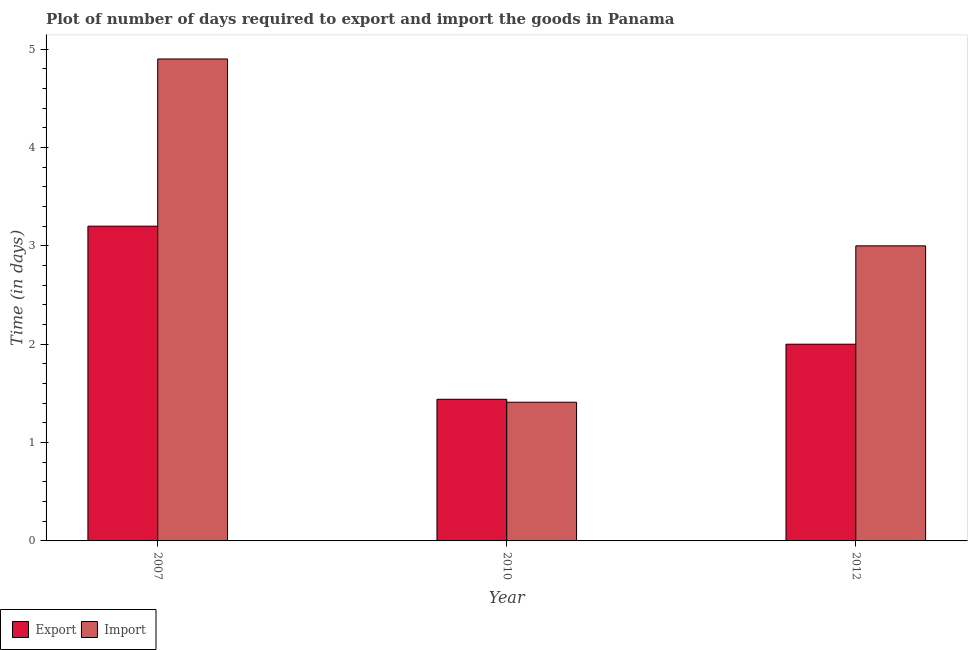How many different coloured bars are there?
Offer a very short reply. 2. What is the label of the 3rd group of bars from the left?
Your answer should be compact. 2012. In how many cases, is the number of bars for a given year not equal to the number of legend labels?
Make the answer very short. 0. Across all years, what is the minimum time required to export?
Make the answer very short. 1.44. In which year was the time required to export minimum?
Keep it short and to the point. 2010. What is the total time required to import in the graph?
Your answer should be very brief. 9.31. What is the difference between the time required to export in 2007 and that in 2012?
Your answer should be very brief. 1.2. What is the difference between the time required to import in 2012 and the time required to export in 2007?
Offer a terse response. -1.9. What is the average time required to export per year?
Offer a very short reply. 2.21. In how many years, is the time required to import greater than 1.2 days?
Offer a very short reply. 3. What is the ratio of the time required to export in 2010 to that in 2012?
Offer a very short reply. 0.72. Is the difference between the time required to import in 2010 and 2012 greater than the difference between the time required to export in 2010 and 2012?
Ensure brevity in your answer.  No. What is the difference between the highest and the second highest time required to export?
Keep it short and to the point. 1.2. What is the difference between the highest and the lowest time required to import?
Provide a short and direct response. 3.49. In how many years, is the time required to import greater than the average time required to import taken over all years?
Ensure brevity in your answer.  1. What does the 2nd bar from the left in 2010 represents?
Make the answer very short. Import. What does the 1st bar from the right in 2012 represents?
Provide a short and direct response. Import. How many bars are there?
Keep it short and to the point. 6. What is the difference between two consecutive major ticks on the Y-axis?
Make the answer very short. 1. Are the values on the major ticks of Y-axis written in scientific E-notation?
Your answer should be compact. No. Does the graph contain any zero values?
Offer a terse response. No. Where does the legend appear in the graph?
Your answer should be compact. Bottom left. What is the title of the graph?
Your response must be concise. Plot of number of days required to export and import the goods in Panama. Does "Taxes on profits and capital gains" appear as one of the legend labels in the graph?
Your answer should be compact. No. What is the label or title of the Y-axis?
Provide a succinct answer. Time (in days). What is the Time (in days) of Import in 2007?
Offer a very short reply. 4.9. What is the Time (in days) in Export in 2010?
Your response must be concise. 1.44. What is the Time (in days) of Import in 2010?
Make the answer very short. 1.41. What is the Time (in days) in Export in 2012?
Keep it short and to the point. 2. Across all years, what is the maximum Time (in days) in Export?
Your answer should be compact. 3.2. Across all years, what is the maximum Time (in days) in Import?
Keep it short and to the point. 4.9. Across all years, what is the minimum Time (in days) in Export?
Keep it short and to the point. 1.44. Across all years, what is the minimum Time (in days) of Import?
Offer a terse response. 1.41. What is the total Time (in days) in Export in the graph?
Make the answer very short. 6.64. What is the total Time (in days) in Import in the graph?
Your response must be concise. 9.31. What is the difference between the Time (in days) of Export in 2007 and that in 2010?
Make the answer very short. 1.76. What is the difference between the Time (in days) in Import in 2007 and that in 2010?
Give a very brief answer. 3.49. What is the difference between the Time (in days) in Export in 2007 and that in 2012?
Provide a succinct answer. 1.2. What is the difference between the Time (in days) of Import in 2007 and that in 2012?
Your answer should be compact. 1.9. What is the difference between the Time (in days) of Export in 2010 and that in 2012?
Your response must be concise. -0.56. What is the difference between the Time (in days) in Import in 2010 and that in 2012?
Keep it short and to the point. -1.59. What is the difference between the Time (in days) in Export in 2007 and the Time (in days) in Import in 2010?
Offer a very short reply. 1.79. What is the difference between the Time (in days) of Export in 2010 and the Time (in days) of Import in 2012?
Your response must be concise. -1.56. What is the average Time (in days) of Export per year?
Provide a short and direct response. 2.21. What is the average Time (in days) in Import per year?
Provide a succinct answer. 3.1. In the year 2012, what is the difference between the Time (in days) of Export and Time (in days) of Import?
Keep it short and to the point. -1. What is the ratio of the Time (in days) in Export in 2007 to that in 2010?
Make the answer very short. 2.22. What is the ratio of the Time (in days) in Import in 2007 to that in 2010?
Offer a very short reply. 3.48. What is the ratio of the Time (in days) of Export in 2007 to that in 2012?
Give a very brief answer. 1.6. What is the ratio of the Time (in days) in Import in 2007 to that in 2012?
Make the answer very short. 1.63. What is the ratio of the Time (in days) in Export in 2010 to that in 2012?
Your response must be concise. 0.72. What is the ratio of the Time (in days) in Import in 2010 to that in 2012?
Your response must be concise. 0.47. What is the difference between the highest and the second highest Time (in days) of Export?
Offer a very short reply. 1.2. What is the difference between the highest and the second highest Time (in days) of Import?
Provide a succinct answer. 1.9. What is the difference between the highest and the lowest Time (in days) in Export?
Give a very brief answer. 1.76. What is the difference between the highest and the lowest Time (in days) of Import?
Make the answer very short. 3.49. 